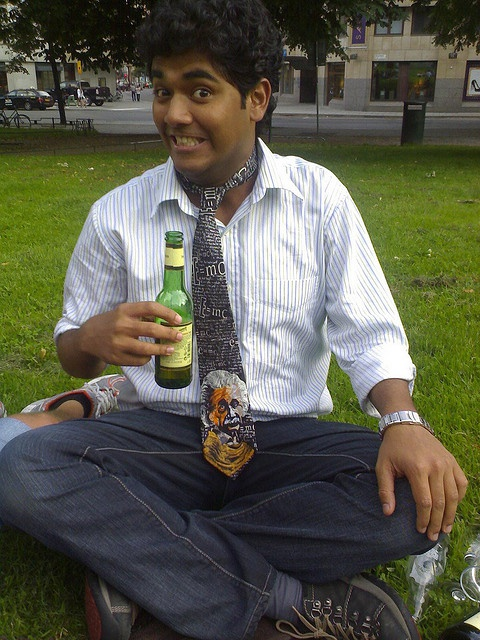Describe the objects in this image and their specific colors. I can see people in black, lightgray, gray, and darkgray tones, tie in black, gray, darkgray, and maroon tones, bottle in black, green, olive, and khaki tones, people in black, darkgray, and gray tones, and car in black, gray, darkgray, and darkgreen tones in this image. 